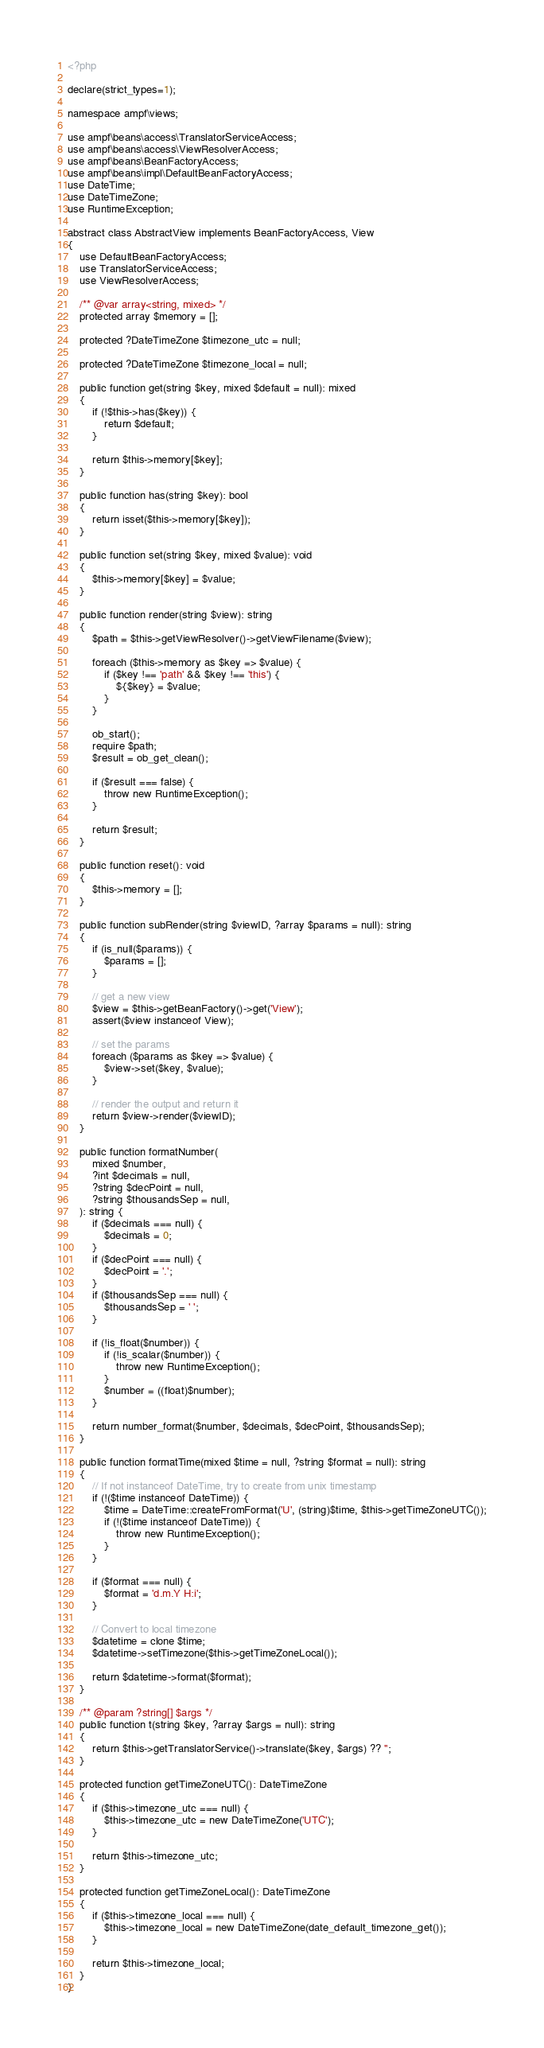<code> <loc_0><loc_0><loc_500><loc_500><_PHP_><?php

declare(strict_types=1);

namespace ampf\views;

use ampf\beans\access\TranslatorServiceAccess;
use ampf\beans\access\ViewResolverAccess;
use ampf\beans\BeanFactoryAccess;
use ampf\beans\impl\DefaultBeanFactoryAccess;
use DateTime;
use DateTimeZone;
use RuntimeException;

abstract class AbstractView implements BeanFactoryAccess, View
{
    use DefaultBeanFactoryAccess;
    use TranslatorServiceAccess;
    use ViewResolverAccess;

    /** @var array<string, mixed> */
    protected array $memory = [];

    protected ?DateTimeZone $timezone_utc = null;

    protected ?DateTimeZone $timezone_local = null;

    public function get(string $key, mixed $default = null): mixed
    {
        if (!$this->has($key)) {
            return $default;
        }

        return $this->memory[$key];
    }

    public function has(string $key): bool
    {
        return isset($this->memory[$key]);
    }

    public function set(string $key, mixed $value): void
    {
        $this->memory[$key] = $value;
    }

    public function render(string $view): string
    {
        $path = $this->getViewResolver()->getViewFilename($view);

        foreach ($this->memory as $key => $value) {
            if ($key !== 'path' && $key !== 'this') {
                ${$key} = $value;
            }
        }

        ob_start();
        require $path;
        $result = ob_get_clean();

        if ($result === false) {
            throw new RuntimeException();
        }

        return $result;
    }

    public function reset(): void
    {
        $this->memory = [];
    }

    public function subRender(string $viewID, ?array $params = null): string
    {
        if (is_null($params)) {
            $params = [];
        }

        // get a new view
        $view = $this->getBeanFactory()->get('View');
        assert($view instanceof View);

        // set the params
        foreach ($params as $key => $value) {
            $view->set($key, $value);
        }

        // render the output and return it
        return $view->render($viewID);
    }

    public function formatNumber(
        mixed $number,
        ?int $decimals = null,
        ?string $decPoint = null,
        ?string $thousandsSep = null,
    ): string {
        if ($decimals === null) {
            $decimals = 0;
        }
        if ($decPoint === null) {
            $decPoint = '.';
        }
        if ($thousandsSep === null) {
            $thousandsSep = ' ';
        }

        if (!is_float($number)) {
            if (!is_scalar($number)) {
                throw new RuntimeException();
            }
            $number = ((float)$number);
        }

        return number_format($number, $decimals, $decPoint, $thousandsSep);
    }

    public function formatTime(mixed $time = null, ?string $format = null): string
    {
        // If not instanceof DateTime, try to create from unix timestamp
        if (!($time instanceof DateTime)) {
            $time = DateTime::createFromFormat('U', (string)$time, $this->getTimeZoneUTC());
            if (!($time instanceof DateTime)) {
                throw new RuntimeException();
            }
        }

        if ($format === null) {
            $format = 'd.m.Y H:i';
        }

        // Convert to local timezone
        $datetime = clone $time;
        $datetime->setTimezone($this->getTimeZoneLocal());

        return $datetime->format($format);
    }

    /** @param ?string[] $args */
    public function t(string $key, ?array $args = null): string
    {
        return $this->getTranslatorService()->translate($key, $args) ?? '';
    }

    protected function getTimeZoneUTC(): DateTimeZone
    {
        if ($this->timezone_utc === null) {
            $this->timezone_utc = new DateTimeZone('UTC');
        }

        return $this->timezone_utc;
    }

    protected function getTimeZoneLocal(): DateTimeZone
    {
        if ($this->timezone_local === null) {
            $this->timezone_local = new DateTimeZone(date_default_timezone_get());
        }

        return $this->timezone_local;
    }
}
</code> 